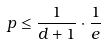<formula> <loc_0><loc_0><loc_500><loc_500>p \leq \frac { 1 } { d + 1 } \cdot \frac { 1 } { e }</formula> 